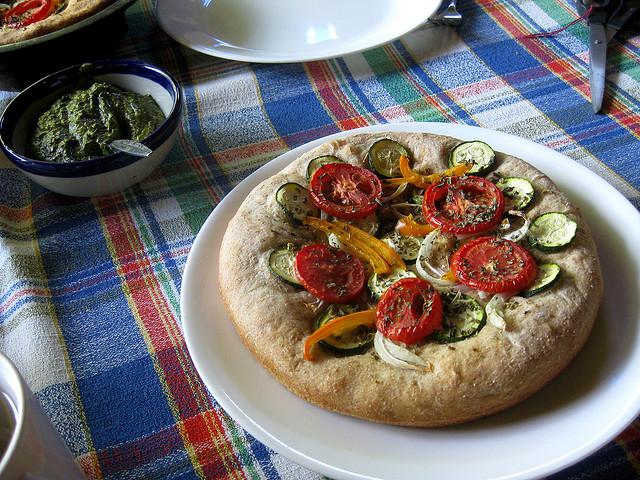What tool is shown?
Short answer required. Scissors. What type of food is this?
Quick response, please. Pizza. What vegetables are on the pizza?
Short answer required. Peppers, tomatoes, onions, and cucumbers. 